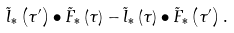Convert formula to latex. <formula><loc_0><loc_0><loc_500><loc_500>\tilde { l } _ { * } \left ( \tau ^ { \prime } \right ) \bullet \tilde { F } _ { * } \left ( \tau \right ) - \tilde { l } _ { * } \left ( \tau \right ) \bullet \tilde { F } _ { * } \left ( \tau ^ { \prime } \right ) .</formula> 